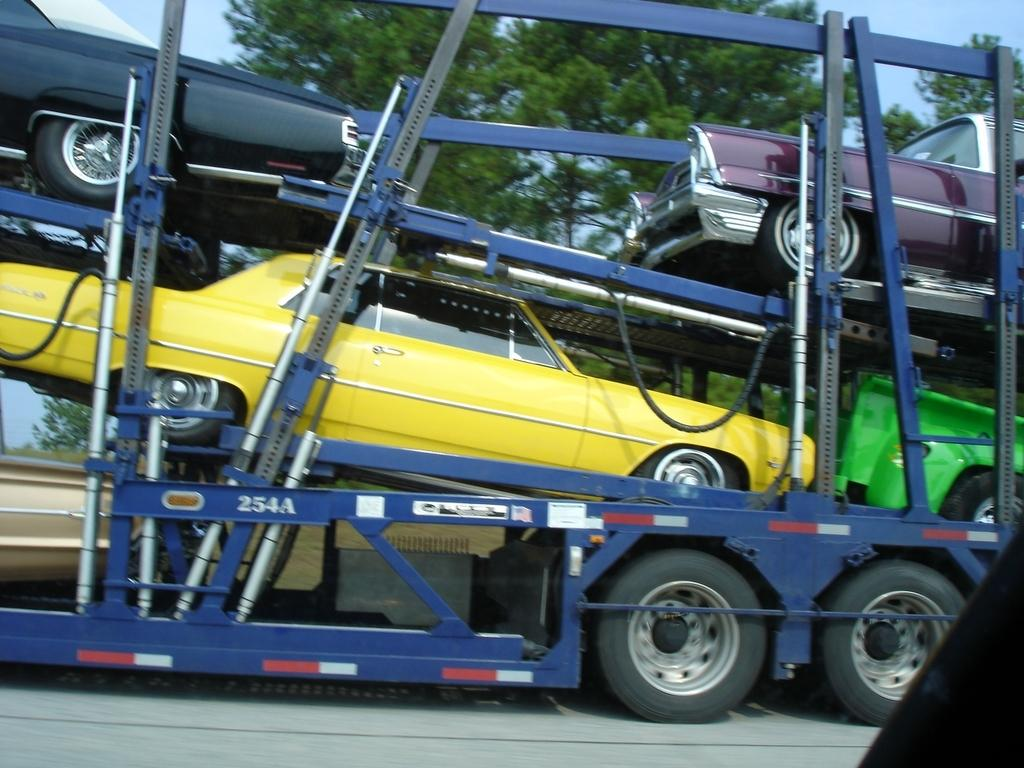What is the main subject of the image? The main subject of the image is cars. How are the cars being transported in the image? The cars are being transported in a truck. What can be seen in the background of the image? There are trees in the background of the image. What type of discovery was made by the ear in the image? There is no ear present in the image, and therefore no discovery can be made by it. 